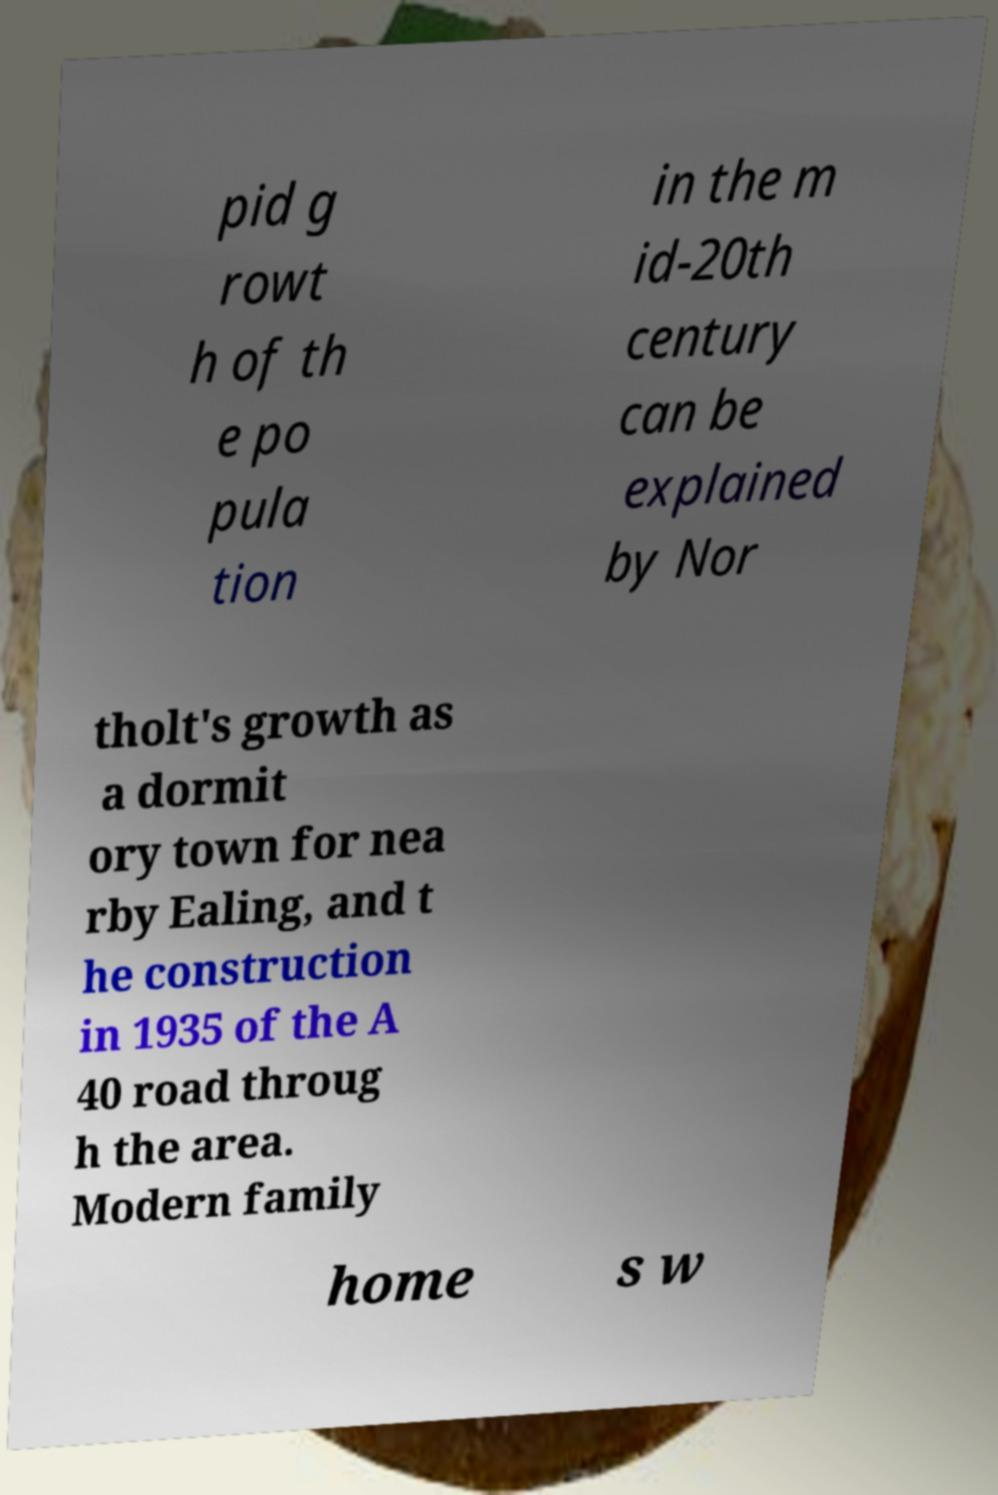Could you assist in decoding the text presented in this image and type it out clearly? pid g rowt h of th e po pula tion in the m id-20th century can be explained by Nor tholt's growth as a dormit ory town for nea rby Ealing, and t he construction in 1935 of the A 40 road throug h the area. Modern family home s w 